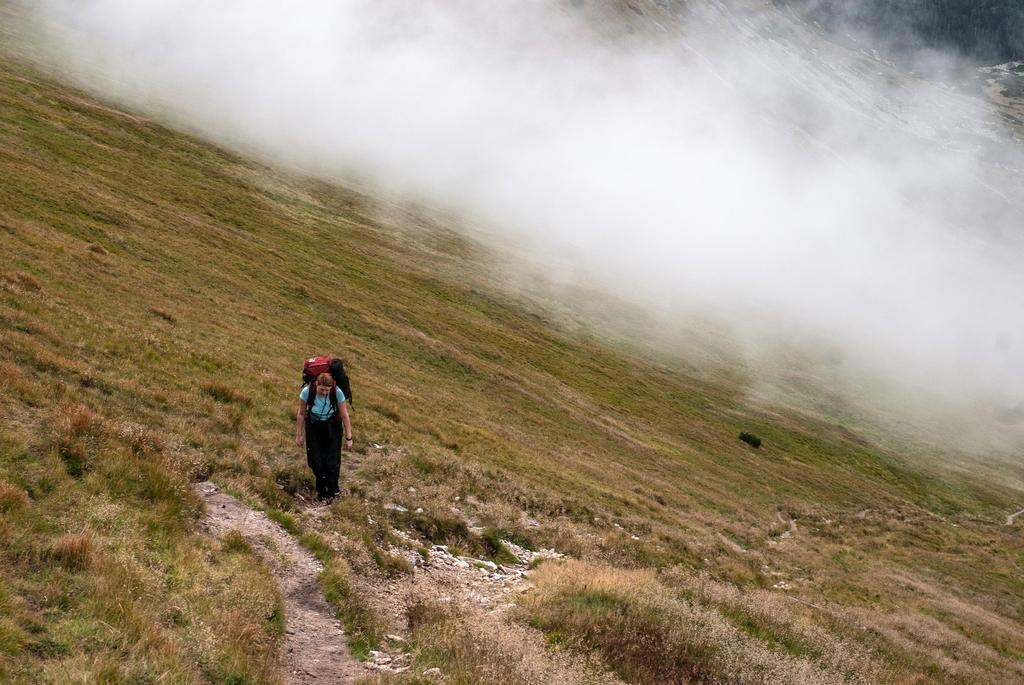What is the main subject of the image? There is a person standing in the image. Where is the person standing? The person is standing on a grass path. What can be seen in the background of the image? There is fog and hills visible in the background of the image. What type of pencil is the person using to draw the aftermath of the payment in the image? There is no pencil or payment depicted in the image; it features a person standing on a grass path with fog and hills in the background. 